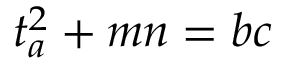<formula> <loc_0><loc_0><loc_500><loc_500>t _ { a } ^ { 2 } + m n = b c</formula> 